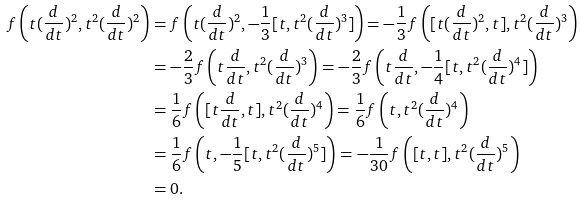<formula> <loc_0><loc_0><loc_500><loc_500>f \left ( t ( \frac { d } { d t } ) ^ { 2 } , t ^ { 2 } ( \frac { d } { d t } ) ^ { 2 } \right ) & = f \left ( t ( \frac { d } { d t } ) ^ { 2 } , - \frac { 1 } { 3 } [ t , t ^ { 2 } ( \frac { d } { d t } ) ^ { 3 } ] \right ) { = - } \frac { 1 } { 3 } f \left ( [ t ( \frac { d } { d t } ) ^ { 2 } , t ] , t ^ { 2 } ( \frac { d } { d t } ) ^ { 3 } \right ) \\ & = - \frac { 2 } { 3 } f \left ( t \frac { d } { d t } , t ^ { 2 } ( \frac { d } { d t } ) ^ { 3 } \right ) = - \frac { 2 } { 3 } f \left ( t \frac { d } { d t } , - \frac { 1 } { 4 } [ t , t ^ { 2 } ( \frac { d } { d t } ) ^ { 4 } ] \right ) \\ & = \frac { 1 } { 6 } f \left ( [ t \frac { d } { d t } , t ] , t ^ { 2 } ( \frac { d } { d t } ) ^ { 4 } \right ) = \frac { 1 } { 6 } f \left ( t , t ^ { 2 } ( \frac { d } { d t } ) ^ { 4 } \right ) \\ & = \frac { 1 } { 6 } f \left ( t , - \frac { 1 } { 5 } [ t , t ^ { 2 } ( \frac { d } { d t } ) ^ { 5 } ] \right ) = - \frac { 1 } { 3 0 } f \left ( [ t , t ] , t ^ { 2 } ( \frac { d } { d t } ) ^ { 5 } \right ) \\ & = 0 .</formula> 